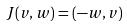<formula> <loc_0><loc_0><loc_500><loc_500>J ( v , w ) = ( - w , v )</formula> 